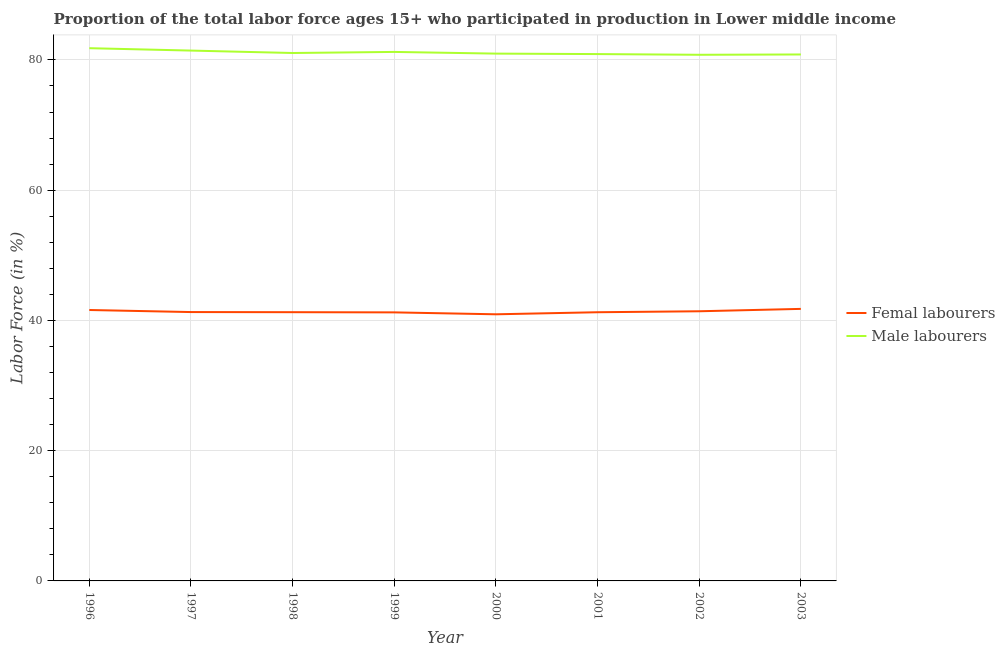Does the line corresponding to percentage of female labor force intersect with the line corresponding to percentage of male labour force?
Provide a succinct answer. No. Is the number of lines equal to the number of legend labels?
Your answer should be compact. Yes. What is the percentage of male labour force in 2002?
Your answer should be very brief. 80.79. Across all years, what is the maximum percentage of female labor force?
Your answer should be very brief. 41.77. Across all years, what is the minimum percentage of female labor force?
Ensure brevity in your answer.  40.94. In which year was the percentage of female labor force minimum?
Your answer should be compact. 2000. What is the total percentage of male labour force in the graph?
Keep it short and to the point. 649.05. What is the difference between the percentage of female labor force in 2000 and that in 2003?
Make the answer very short. -0.83. What is the difference between the percentage of female labor force in 1999 and the percentage of male labour force in 1996?
Provide a succinct answer. -40.57. What is the average percentage of male labour force per year?
Provide a succinct answer. 81.13. In the year 1997, what is the difference between the percentage of male labour force and percentage of female labor force?
Your answer should be very brief. 40.15. What is the ratio of the percentage of male labour force in 1997 to that in 2001?
Give a very brief answer. 1.01. Is the difference between the percentage of male labour force in 1997 and 2002 greater than the difference between the percentage of female labor force in 1997 and 2002?
Provide a short and direct response. Yes. What is the difference between the highest and the second highest percentage of female labor force?
Make the answer very short. 0.17. What is the difference between the highest and the lowest percentage of female labor force?
Offer a terse response. 0.83. Does the percentage of male labour force monotonically increase over the years?
Your answer should be compact. No. How many lines are there?
Provide a succinct answer. 2. How many years are there in the graph?
Your answer should be very brief. 8. What is the difference between two consecutive major ticks on the Y-axis?
Your answer should be compact. 20. Are the values on the major ticks of Y-axis written in scientific E-notation?
Keep it short and to the point. No. Where does the legend appear in the graph?
Your answer should be compact. Center right. How many legend labels are there?
Keep it short and to the point. 2. What is the title of the graph?
Your answer should be compact. Proportion of the total labor force ages 15+ who participated in production in Lower middle income. What is the Labor Force (in %) of Femal labourers in 1996?
Your answer should be compact. 41.6. What is the Labor Force (in %) in Male labourers in 1996?
Provide a short and direct response. 81.81. What is the Labor Force (in %) of Femal labourers in 1997?
Give a very brief answer. 41.29. What is the Labor Force (in %) in Male labourers in 1997?
Ensure brevity in your answer.  81.44. What is the Labor Force (in %) in Femal labourers in 1998?
Your answer should be compact. 41.27. What is the Labor Force (in %) of Male labourers in 1998?
Make the answer very short. 81.07. What is the Labor Force (in %) in Femal labourers in 1999?
Make the answer very short. 41.24. What is the Labor Force (in %) in Male labourers in 1999?
Your response must be concise. 81.23. What is the Labor Force (in %) in Femal labourers in 2000?
Your answer should be compact. 40.94. What is the Labor Force (in %) of Male labourers in 2000?
Offer a very short reply. 80.97. What is the Labor Force (in %) of Femal labourers in 2001?
Make the answer very short. 41.26. What is the Labor Force (in %) of Male labourers in 2001?
Provide a succinct answer. 80.9. What is the Labor Force (in %) of Femal labourers in 2002?
Make the answer very short. 41.41. What is the Labor Force (in %) of Male labourers in 2002?
Keep it short and to the point. 80.79. What is the Labor Force (in %) in Femal labourers in 2003?
Your answer should be very brief. 41.77. What is the Labor Force (in %) of Male labourers in 2003?
Offer a very short reply. 80.84. Across all years, what is the maximum Labor Force (in %) in Femal labourers?
Your answer should be very brief. 41.77. Across all years, what is the maximum Labor Force (in %) in Male labourers?
Your answer should be compact. 81.81. Across all years, what is the minimum Labor Force (in %) in Femal labourers?
Provide a succinct answer. 40.94. Across all years, what is the minimum Labor Force (in %) in Male labourers?
Keep it short and to the point. 80.79. What is the total Labor Force (in %) in Femal labourers in the graph?
Keep it short and to the point. 330.77. What is the total Labor Force (in %) of Male labourers in the graph?
Your answer should be compact. 649.05. What is the difference between the Labor Force (in %) in Femal labourers in 1996 and that in 1997?
Offer a very short reply. 0.32. What is the difference between the Labor Force (in %) of Male labourers in 1996 and that in 1997?
Your answer should be compact. 0.37. What is the difference between the Labor Force (in %) of Femal labourers in 1996 and that in 1998?
Provide a short and direct response. 0.34. What is the difference between the Labor Force (in %) of Male labourers in 1996 and that in 1998?
Offer a terse response. 0.74. What is the difference between the Labor Force (in %) of Femal labourers in 1996 and that in 1999?
Your response must be concise. 0.37. What is the difference between the Labor Force (in %) of Male labourers in 1996 and that in 1999?
Offer a terse response. 0.58. What is the difference between the Labor Force (in %) in Femal labourers in 1996 and that in 2000?
Make the answer very short. 0.66. What is the difference between the Labor Force (in %) in Male labourers in 1996 and that in 2000?
Offer a very short reply. 0.83. What is the difference between the Labor Force (in %) of Femal labourers in 1996 and that in 2001?
Offer a terse response. 0.34. What is the difference between the Labor Force (in %) of Male labourers in 1996 and that in 2001?
Offer a terse response. 0.91. What is the difference between the Labor Force (in %) of Femal labourers in 1996 and that in 2002?
Your answer should be compact. 0.19. What is the difference between the Labor Force (in %) in Male labourers in 1996 and that in 2002?
Give a very brief answer. 1.01. What is the difference between the Labor Force (in %) of Femal labourers in 1996 and that in 2003?
Give a very brief answer. -0.17. What is the difference between the Labor Force (in %) of Male labourers in 1996 and that in 2003?
Your response must be concise. 0.96. What is the difference between the Labor Force (in %) of Femal labourers in 1997 and that in 1998?
Make the answer very short. 0.02. What is the difference between the Labor Force (in %) of Male labourers in 1997 and that in 1998?
Provide a short and direct response. 0.37. What is the difference between the Labor Force (in %) in Femal labourers in 1997 and that in 1999?
Your answer should be very brief. 0.05. What is the difference between the Labor Force (in %) of Male labourers in 1997 and that in 1999?
Offer a terse response. 0.21. What is the difference between the Labor Force (in %) in Femal labourers in 1997 and that in 2000?
Ensure brevity in your answer.  0.34. What is the difference between the Labor Force (in %) in Male labourers in 1997 and that in 2000?
Offer a terse response. 0.47. What is the difference between the Labor Force (in %) in Femal labourers in 1997 and that in 2001?
Provide a short and direct response. 0.03. What is the difference between the Labor Force (in %) in Male labourers in 1997 and that in 2001?
Your answer should be compact. 0.54. What is the difference between the Labor Force (in %) in Femal labourers in 1997 and that in 2002?
Your answer should be compact. -0.12. What is the difference between the Labor Force (in %) of Male labourers in 1997 and that in 2002?
Provide a succinct answer. 0.65. What is the difference between the Labor Force (in %) of Femal labourers in 1997 and that in 2003?
Offer a terse response. -0.49. What is the difference between the Labor Force (in %) in Male labourers in 1997 and that in 2003?
Offer a very short reply. 0.6. What is the difference between the Labor Force (in %) of Male labourers in 1998 and that in 1999?
Ensure brevity in your answer.  -0.16. What is the difference between the Labor Force (in %) in Femal labourers in 1998 and that in 2000?
Keep it short and to the point. 0.32. What is the difference between the Labor Force (in %) in Male labourers in 1998 and that in 2000?
Provide a succinct answer. 0.09. What is the difference between the Labor Force (in %) of Femal labourers in 1998 and that in 2001?
Offer a terse response. 0.01. What is the difference between the Labor Force (in %) of Male labourers in 1998 and that in 2001?
Provide a short and direct response. 0.17. What is the difference between the Labor Force (in %) of Femal labourers in 1998 and that in 2002?
Provide a short and direct response. -0.14. What is the difference between the Labor Force (in %) in Male labourers in 1998 and that in 2002?
Keep it short and to the point. 0.27. What is the difference between the Labor Force (in %) of Femal labourers in 1998 and that in 2003?
Ensure brevity in your answer.  -0.51. What is the difference between the Labor Force (in %) of Male labourers in 1998 and that in 2003?
Make the answer very short. 0.23. What is the difference between the Labor Force (in %) of Femal labourers in 1999 and that in 2000?
Provide a succinct answer. 0.29. What is the difference between the Labor Force (in %) in Male labourers in 1999 and that in 2000?
Your answer should be very brief. 0.26. What is the difference between the Labor Force (in %) of Femal labourers in 1999 and that in 2001?
Your response must be concise. -0.02. What is the difference between the Labor Force (in %) in Male labourers in 1999 and that in 2001?
Give a very brief answer. 0.33. What is the difference between the Labor Force (in %) in Femal labourers in 1999 and that in 2002?
Keep it short and to the point. -0.17. What is the difference between the Labor Force (in %) in Male labourers in 1999 and that in 2002?
Your answer should be compact. 0.44. What is the difference between the Labor Force (in %) in Femal labourers in 1999 and that in 2003?
Give a very brief answer. -0.54. What is the difference between the Labor Force (in %) in Male labourers in 1999 and that in 2003?
Offer a very short reply. 0.39. What is the difference between the Labor Force (in %) in Femal labourers in 2000 and that in 2001?
Provide a succinct answer. -0.32. What is the difference between the Labor Force (in %) of Male labourers in 2000 and that in 2001?
Offer a very short reply. 0.07. What is the difference between the Labor Force (in %) of Femal labourers in 2000 and that in 2002?
Your answer should be very brief. -0.47. What is the difference between the Labor Force (in %) of Male labourers in 2000 and that in 2002?
Your answer should be compact. 0.18. What is the difference between the Labor Force (in %) of Femal labourers in 2000 and that in 2003?
Offer a very short reply. -0.83. What is the difference between the Labor Force (in %) in Male labourers in 2000 and that in 2003?
Your answer should be very brief. 0.13. What is the difference between the Labor Force (in %) of Femal labourers in 2001 and that in 2002?
Your answer should be compact. -0.15. What is the difference between the Labor Force (in %) of Male labourers in 2001 and that in 2002?
Keep it short and to the point. 0.11. What is the difference between the Labor Force (in %) of Femal labourers in 2001 and that in 2003?
Make the answer very short. -0.51. What is the difference between the Labor Force (in %) of Male labourers in 2001 and that in 2003?
Offer a terse response. 0.06. What is the difference between the Labor Force (in %) of Femal labourers in 2002 and that in 2003?
Provide a short and direct response. -0.37. What is the difference between the Labor Force (in %) in Male labourers in 2002 and that in 2003?
Your response must be concise. -0.05. What is the difference between the Labor Force (in %) in Femal labourers in 1996 and the Labor Force (in %) in Male labourers in 1997?
Make the answer very short. -39.84. What is the difference between the Labor Force (in %) of Femal labourers in 1996 and the Labor Force (in %) of Male labourers in 1998?
Offer a very short reply. -39.47. What is the difference between the Labor Force (in %) in Femal labourers in 1996 and the Labor Force (in %) in Male labourers in 1999?
Provide a succinct answer. -39.63. What is the difference between the Labor Force (in %) of Femal labourers in 1996 and the Labor Force (in %) of Male labourers in 2000?
Provide a succinct answer. -39.37. What is the difference between the Labor Force (in %) in Femal labourers in 1996 and the Labor Force (in %) in Male labourers in 2001?
Offer a very short reply. -39.3. What is the difference between the Labor Force (in %) of Femal labourers in 1996 and the Labor Force (in %) of Male labourers in 2002?
Make the answer very short. -39.19. What is the difference between the Labor Force (in %) of Femal labourers in 1996 and the Labor Force (in %) of Male labourers in 2003?
Your answer should be very brief. -39.24. What is the difference between the Labor Force (in %) of Femal labourers in 1997 and the Labor Force (in %) of Male labourers in 1998?
Give a very brief answer. -39.78. What is the difference between the Labor Force (in %) in Femal labourers in 1997 and the Labor Force (in %) in Male labourers in 1999?
Offer a terse response. -39.94. What is the difference between the Labor Force (in %) of Femal labourers in 1997 and the Labor Force (in %) of Male labourers in 2000?
Your answer should be very brief. -39.69. What is the difference between the Labor Force (in %) of Femal labourers in 1997 and the Labor Force (in %) of Male labourers in 2001?
Keep it short and to the point. -39.61. What is the difference between the Labor Force (in %) in Femal labourers in 1997 and the Labor Force (in %) in Male labourers in 2002?
Keep it short and to the point. -39.51. What is the difference between the Labor Force (in %) in Femal labourers in 1997 and the Labor Force (in %) in Male labourers in 2003?
Your answer should be compact. -39.56. What is the difference between the Labor Force (in %) of Femal labourers in 1998 and the Labor Force (in %) of Male labourers in 1999?
Your response must be concise. -39.96. What is the difference between the Labor Force (in %) in Femal labourers in 1998 and the Labor Force (in %) in Male labourers in 2000?
Keep it short and to the point. -39.71. What is the difference between the Labor Force (in %) in Femal labourers in 1998 and the Labor Force (in %) in Male labourers in 2001?
Give a very brief answer. -39.63. What is the difference between the Labor Force (in %) of Femal labourers in 1998 and the Labor Force (in %) of Male labourers in 2002?
Provide a succinct answer. -39.53. What is the difference between the Labor Force (in %) of Femal labourers in 1998 and the Labor Force (in %) of Male labourers in 2003?
Make the answer very short. -39.57. What is the difference between the Labor Force (in %) of Femal labourers in 1999 and the Labor Force (in %) of Male labourers in 2000?
Your answer should be compact. -39.74. What is the difference between the Labor Force (in %) in Femal labourers in 1999 and the Labor Force (in %) in Male labourers in 2001?
Keep it short and to the point. -39.66. What is the difference between the Labor Force (in %) of Femal labourers in 1999 and the Labor Force (in %) of Male labourers in 2002?
Keep it short and to the point. -39.56. What is the difference between the Labor Force (in %) of Femal labourers in 1999 and the Labor Force (in %) of Male labourers in 2003?
Offer a very short reply. -39.6. What is the difference between the Labor Force (in %) of Femal labourers in 2000 and the Labor Force (in %) of Male labourers in 2001?
Ensure brevity in your answer.  -39.96. What is the difference between the Labor Force (in %) in Femal labourers in 2000 and the Labor Force (in %) in Male labourers in 2002?
Offer a terse response. -39.85. What is the difference between the Labor Force (in %) in Femal labourers in 2000 and the Labor Force (in %) in Male labourers in 2003?
Your answer should be compact. -39.9. What is the difference between the Labor Force (in %) in Femal labourers in 2001 and the Labor Force (in %) in Male labourers in 2002?
Your response must be concise. -39.53. What is the difference between the Labor Force (in %) in Femal labourers in 2001 and the Labor Force (in %) in Male labourers in 2003?
Offer a very short reply. -39.58. What is the difference between the Labor Force (in %) of Femal labourers in 2002 and the Labor Force (in %) of Male labourers in 2003?
Provide a succinct answer. -39.43. What is the average Labor Force (in %) in Femal labourers per year?
Your answer should be compact. 41.35. What is the average Labor Force (in %) of Male labourers per year?
Your answer should be very brief. 81.13. In the year 1996, what is the difference between the Labor Force (in %) in Femal labourers and Labor Force (in %) in Male labourers?
Ensure brevity in your answer.  -40.2. In the year 1997, what is the difference between the Labor Force (in %) of Femal labourers and Labor Force (in %) of Male labourers?
Ensure brevity in your answer.  -40.15. In the year 1998, what is the difference between the Labor Force (in %) in Femal labourers and Labor Force (in %) in Male labourers?
Give a very brief answer. -39.8. In the year 1999, what is the difference between the Labor Force (in %) of Femal labourers and Labor Force (in %) of Male labourers?
Provide a succinct answer. -39.99. In the year 2000, what is the difference between the Labor Force (in %) in Femal labourers and Labor Force (in %) in Male labourers?
Offer a terse response. -40.03. In the year 2001, what is the difference between the Labor Force (in %) in Femal labourers and Labor Force (in %) in Male labourers?
Keep it short and to the point. -39.64. In the year 2002, what is the difference between the Labor Force (in %) of Femal labourers and Labor Force (in %) of Male labourers?
Offer a very short reply. -39.38. In the year 2003, what is the difference between the Labor Force (in %) in Femal labourers and Labor Force (in %) in Male labourers?
Make the answer very short. -39.07. What is the ratio of the Labor Force (in %) in Femal labourers in 1996 to that in 1997?
Keep it short and to the point. 1.01. What is the ratio of the Labor Force (in %) in Male labourers in 1996 to that in 1998?
Make the answer very short. 1.01. What is the ratio of the Labor Force (in %) in Femal labourers in 1996 to that in 1999?
Give a very brief answer. 1.01. What is the ratio of the Labor Force (in %) in Male labourers in 1996 to that in 1999?
Your answer should be compact. 1.01. What is the ratio of the Labor Force (in %) of Femal labourers in 1996 to that in 2000?
Your answer should be compact. 1.02. What is the ratio of the Labor Force (in %) of Male labourers in 1996 to that in 2000?
Make the answer very short. 1.01. What is the ratio of the Labor Force (in %) in Femal labourers in 1996 to that in 2001?
Provide a short and direct response. 1.01. What is the ratio of the Labor Force (in %) of Male labourers in 1996 to that in 2001?
Provide a succinct answer. 1.01. What is the ratio of the Labor Force (in %) of Femal labourers in 1996 to that in 2002?
Offer a terse response. 1. What is the ratio of the Labor Force (in %) in Male labourers in 1996 to that in 2002?
Give a very brief answer. 1.01. What is the ratio of the Labor Force (in %) of Femal labourers in 1996 to that in 2003?
Your answer should be very brief. 1. What is the ratio of the Labor Force (in %) in Male labourers in 1996 to that in 2003?
Ensure brevity in your answer.  1.01. What is the ratio of the Labor Force (in %) of Femal labourers in 1997 to that in 1998?
Make the answer very short. 1. What is the ratio of the Labor Force (in %) of Male labourers in 1997 to that in 1998?
Your response must be concise. 1. What is the ratio of the Labor Force (in %) in Femal labourers in 1997 to that in 2000?
Your answer should be compact. 1.01. What is the ratio of the Labor Force (in %) of Femal labourers in 1997 to that in 2002?
Your response must be concise. 1. What is the ratio of the Labor Force (in %) in Male labourers in 1997 to that in 2002?
Ensure brevity in your answer.  1.01. What is the ratio of the Labor Force (in %) in Femal labourers in 1997 to that in 2003?
Your answer should be very brief. 0.99. What is the ratio of the Labor Force (in %) of Male labourers in 1997 to that in 2003?
Your response must be concise. 1.01. What is the ratio of the Labor Force (in %) of Femal labourers in 1998 to that in 2000?
Offer a terse response. 1.01. What is the ratio of the Labor Force (in %) of Male labourers in 1998 to that in 2000?
Ensure brevity in your answer.  1. What is the ratio of the Labor Force (in %) in Femal labourers in 1998 to that in 2001?
Your response must be concise. 1. What is the ratio of the Labor Force (in %) in Femal labourers in 1998 to that in 2003?
Give a very brief answer. 0.99. What is the ratio of the Labor Force (in %) of Male labourers in 1998 to that in 2003?
Your answer should be very brief. 1. What is the ratio of the Labor Force (in %) of Femal labourers in 1999 to that in 2000?
Keep it short and to the point. 1.01. What is the ratio of the Labor Force (in %) of Femal labourers in 1999 to that in 2002?
Keep it short and to the point. 1. What is the ratio of the Labor Force (in %) in Male labourers in 1999 to that in 2002?
Your answer should be compact. 1.01. What is the ratio of the Labor Force (in %) in Femal labourers in 1999 to that in 2003?
Keep it short and to the point. 0.99. What is the ratio of the Labor Force (in %) in Male labourers in 1999 to that in 2003?
Your response must be concise. 1. What is the ratio of the Labor Force (in %) in Male labourers in 2000 to that in 2001?
Ensure brevity in your answer.  1. What is the ratio of the Labor Force (in %) of Femal labourers in 2000 to that in 2002?
Offer a terse response. 0.99. What is the ratio of the Labor Force (in %) in Femal labourers in 2000 to that in 2003?
Offer a terse response. 0.98. What is the ratio of the Labor Force (in %) of Male labourers in 2000 to that in 2003?
Your response must be concise. 1. What is the ratio of the Labor Force (in %) of Femal labourers in 2002 to that in 2003?
Give a very brief answer. 0.99. What is the ratio of the Labor Force (in %) in Male labourers in 2002 to that in 2003?
Your answer should be compact. 1. What is the difference between the highest and the second highest Labor Force (in %) in Femal labourers?
Provide a succinct answer. 0.17. What is the difference between the highest and the second highest Labor Force (in %) of Male labourers?
Your answer should be very brief. 0.37. What is the difference between the highest and the lowest Labor Force (in %) of Femal labourers?
Provide a short and direct response. 0.83. What is the difference between the highest and the lowest Labor Force (in %) in Male labourers?
Your response must be concise. 1.01. 